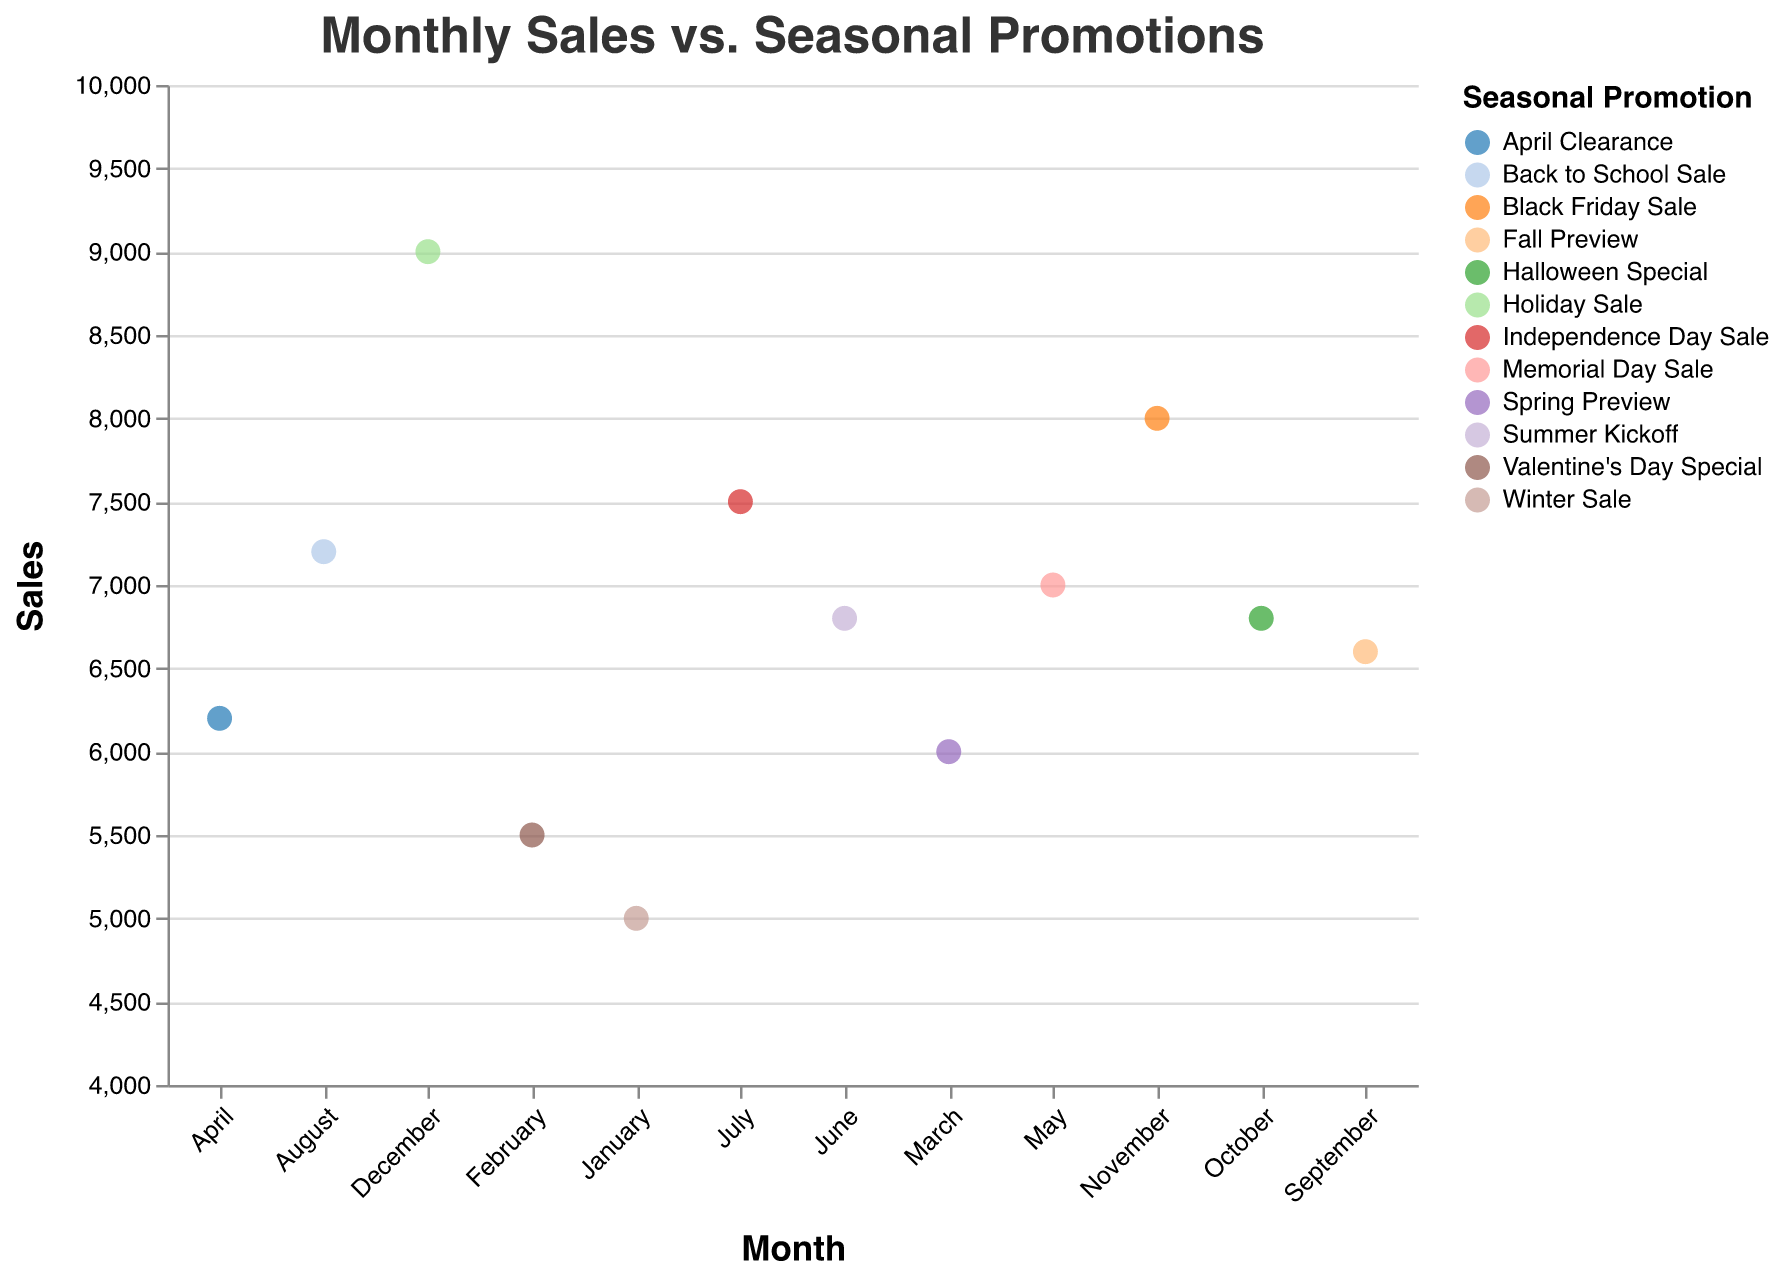what is the title of the figure? The title of the figure is located at the top and is visually distinct, generally in a larger font size. The title provides information on what the chart represents.
Answer: Monthly Sales vs. Seasonal Promotions how many different seasonal promotions are depicted in the chart? Count the unique number of promotions listed in the chart's legend or observed on the scatter plot. Each color in the scatter plot represents a different promotion.
Answer: 12 which month had the highest sales? Locate the highest point on the y-axis (Sales) and then identify the corresponding month on the x-axis. The tooltip also helps by showing the exact values.
Answer: December which promotions occurred during the spring months (March, April, and May)? Identify the points for March, April, and May on the scatter plot. Then, identify the corresponding promotion for each of these months using the color legend or the tooltip.
Answer: Spring Preview, April Clearance, Memorial Day Sale which month had higher sales: June or September? Compare the y-values (Sales) of the data points for June and September. Use the tooltip or direct visualization of the points on the scatter plot.
Answer: June what is the combined sales for the months of February and March? Add the sales values for February and March. February has sales of 5500 and March has sales of 6000. Therefore, 5500 + 6000 = 11500.
Answer: 11500 which promotion is associated with the highest sales? Locate the data point with the highest sales value on the y-axis and see the associated promotion. The tooltip can also help identify this promotion.
Answer: Holiday Sale how do the sales in July compare to the sales in January? Compare the y-values (Sales) of the data points for July and January. Use the tooltip or direct visualization to interpret the difference. July has 7500 sales and January has 5000 sales, so July has higher sales.
Answer: July has higher sales what is the average sales for the winter months (December, January, and February)? Calculate the average of the sales values for December (9000), January (5000), and February (5500). The sum is 9000 + 5000 + 5500 = 19500. The average is 19500 / 3 = 6500.
Answer: 6500 does the promotion in August have higher sales than that in October? Compare the sales value for August and October. August has a sales value of 7200 and October has a value of 6800.
Answer: Yes, August has higher sales 